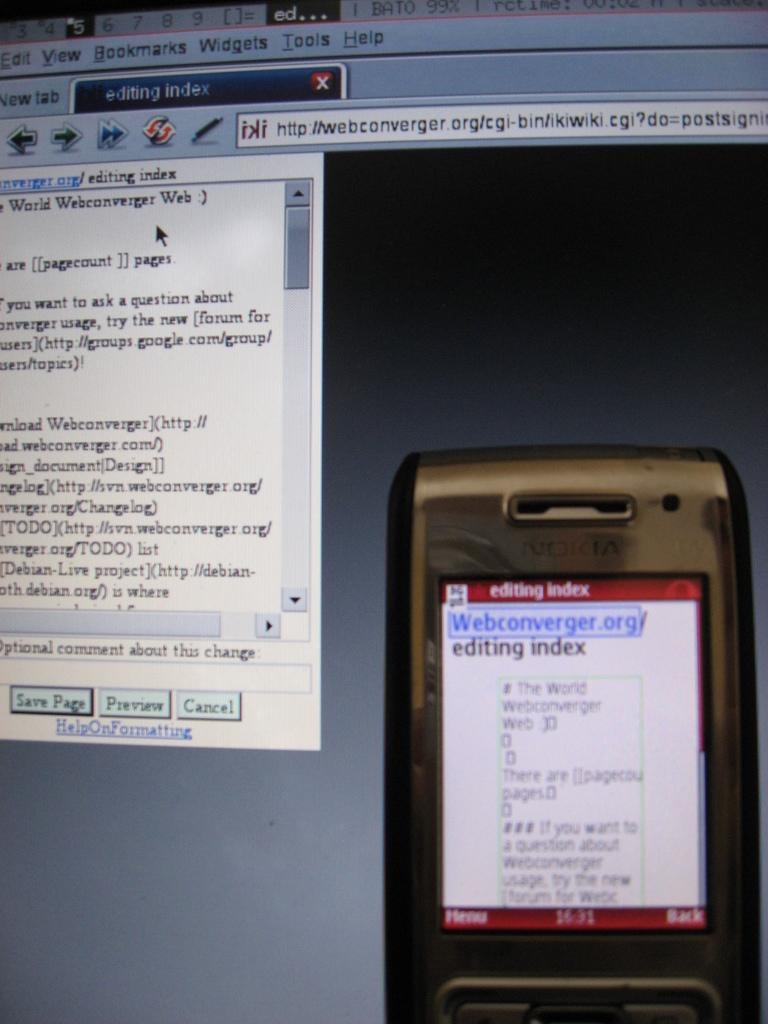<image>
Render a clear and concise summary of the photo. A phone in front of a computer model is on the editing index. 